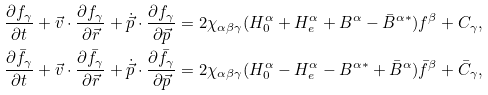Convert formula to latex. <formula><loc_0><loc_0><loc_500><loc_500>\frac { \partial f _ { \gamma } } { \partial t } + \vec { v } \cdot \frac { \partial f _ { \gamma } } { \partial \vec { r } } + \dot { \vec { p } } \cdot \frac { \partial f _ { \gamma } } { \partial \vec { p } } & = 2 \chi _ { \alpha \beta \gamma } ( H _ { 0 } ^ { \alpha } + H _ { e } ^ { \alpha } + B ^ { \alpha } - \bar { B } ^ { \alpha * } ) f ^ { \beta } + C _ { \gamma } , \\ \frac { \partial \bar { f } _ { \gamma } } { \partial t } + \vec { v } \cdot \frac { \partial \bar { f } _ { \gamma } } { \partial \vec { r } } + \dot { \vec { p } } \cdot \frac { \partial \bar { f } _ { \gamma } } { \partial \vec { p } } & = 2 \chi _ { \alpha \beta \gamma } ( H _ { 0 } ^ { \alpha } - H _ { e } ^ { \alpha } - B ^ { \alpha * } + \bar { B } ^ { \alpha } ) \bar { f } ^ { \beta } + \bar { C } _ { \gamma } ,</formula> 